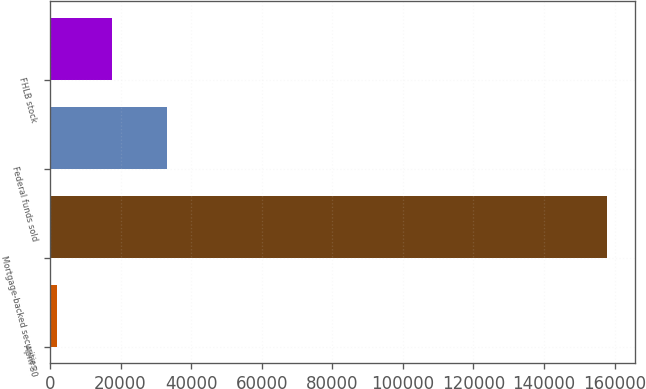<chart> <loc_0><loc_0><loc_500><loc_500><bar_chart><fcel>April 30<fcel>Mortgage-backed securities<fcel>Federal funds sold<fcel>FHLB stock<nl><fcel>2011<fcel>157970<fcel>33202.8<fcel>17606.9<nl></chart> 